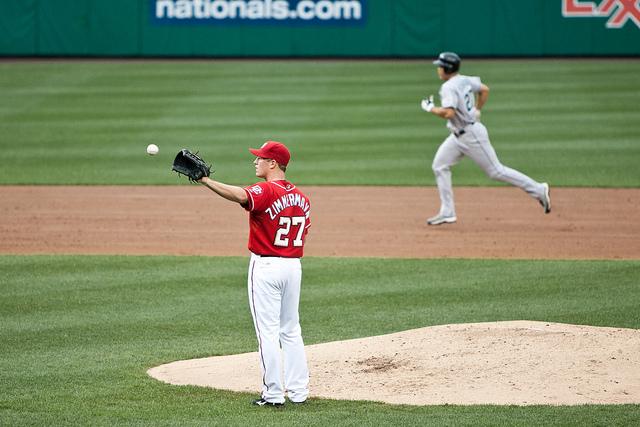What is the pitcher's last name?
Short answer required. Zimmerman. What color is the pitchers Jersey?
Write a very short answer. Red. What sport are the players playing?
Be succinct. Baseball. How many stripes are on each man's pants?
Answer briefly. 1. What number is the pitcher?
Write a very short answer. 27. 